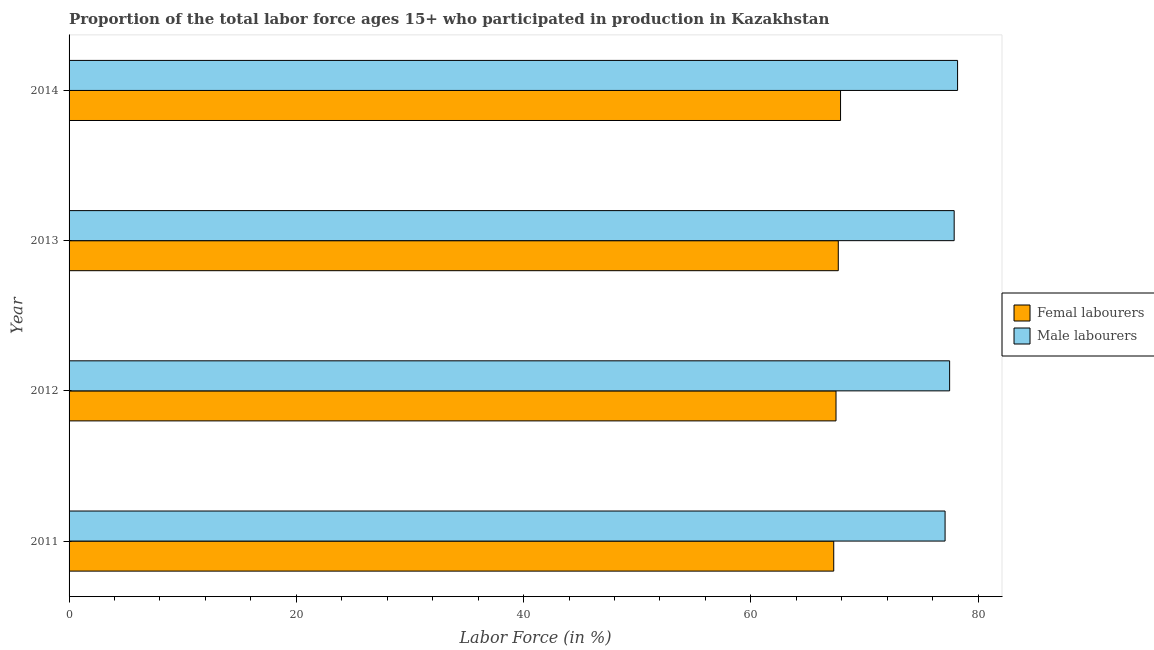How many different coloured bars are there?
Your response must be concise. 2. Are the number of bars per tick equal to the number of legend labels?
Offer a terse response. Yes. Are the number of bars on each tick of the Y-axis equal?
Provide a short and direct response. Yes. How many bars are there on the 1st tick from the bottom?
Your answer should be compact. 2. What is the label of the 1st group of bars from the top?
Give a very brief answer. 2014. What is the percentage of male labour force in 2011?
Provide a short and direct response. 77.1. Across all years, what is the maximum percentage of female labor force?
Provide a succinct answer. 67.9. Across all years, what is the minimum percentage of female labor force?
Ensure brevity in your answer.  67.3. In which year was the percentage of male labour force maximum?
Provide a short and direct response. 2014. What is the total percentage of male labour force in the graph?
Provide a short and direct response. 310.7. What is the difference between the percentage of male labour force in 2011 and the percentage of female labor force in 2012?
Give a very brief answer. 9.6. What is the average percentage of male labour force per year?
Your response must be concise. 77.67. Is the difference between the percentage of female labor force in 2012 and 2014 greater than the difference between the percentage of male labour force in 2012 and 2014?
Your answer should be very brief. Yes. What is the difference between the highest and the second highest percentage of female labor force?
Ensure brevity in your answer.  0.2. What is the difference between the highest and the lowest percentage of male labour force?
Offer a terse response. 1.1. In how many years, is the percentage of male labour force greater than the average percentage of male labour force taken over all years?
Keep it short and to the point. 2. What does the 1st bar from the top in 2012 represents?
Give a very brief answer. Male labourers. What does the 1st bar from the bottom in 2012 represents?
Ensure brevity in your answer.  Femal labourers. How many bars are there?
Offer a terse response. 8. Are all the bars in the graph horizontal?
Provide a succinct answer. Yes. How many years are there in the graph?
Ensure brevity in your answer.  4. What is the difference between two consecutive major ticks on the X-axis?
Provide a short and direct response. 20. Are the values on the major ticks of X-axis written in scientific E-notation?
Your answer should be very brief. No. Does the graph contain grids?
Make the answer very short. No. Where does the legend appear in the graph?
Provide a short and direct response. Center right. How are the legend labels stacked?
Offer a terse response. Vertical. What is the title of the graph?
Your response must be concise. Proportion of the total labor force ages 15+ who participated in production in Kazakhstan. What is the label or title of the Y-axis?
Your answer should be compact. Year. What is the Labor Force (in %) in Femal labourers in 2011?
Provide a short and direct response. 67.3. What is the Labor Force (in %) of Male labourers in 2011?
Your answer should be very brief. 77.1. What is the Labor Force (in %) of Femal labourers in 2012?
Offer a very short reply. 67.5. What is the Labor Force (in %) of Male labourers in 2012?
Provide a succinct answer. 77.5. What is the Labor Force (in %) of Femal labourers in 2013?
Offer a terse response. 67.7. What is the Labor Force (in %) in Male labourers in 2013?
Provide a succinct answer. 77.9. What is the Labor Force (in %) of Femal labourers in 2014?
Keep it short and to the point. 67.9. What is the Labor Force (in %) of Male labourers in 2014?
Keep it short and to the point. 78.2. Across all years, what is the maximum Labor Force (in %) of Femal labourers?
Offer a very short reply. 67.9. Across all years, what is the maximum Labor Force (in %) in Male labourers?
Offer a terse response. 78.2. Across all years, what is the minimum Labor Force (in %) in Femal labourers?
Offer a very short reply. 67.3. Across all years, what is the minimum Labor Force (in %) in Male labourers?
Give a very brief answer. 77.1. What is the total Labor Force (in %) of Femal labourers in the graph?
Ensure brevity in your answer.  270.4. What is the total Labor Force (in %) of Male labourers in the graph?
Offer a very short reply. 310.7. What is the difference between the Labor Force (in %) in Femal labourers in 2011 and that in 2012?
Make the answer very short. -0.2. What is the difference between the Labor Force (in %) in Femal labourers in 2012 and that in 2014?
Your response must be concise. -0.4. What is the difference between the Labor Force (in %) of Femal labourers in 2013 and that in 2014?
Give a very brief answer. -0.2. What is the difference between the Labor Force (in %) in Male labourers in 2013 and that in 2014?
Your response must be concise. -0.3. What is the difference between the Labor Force (in %) in Femal labourers in 2011 and the Labor Force (in %) in Male labourers in 2012?
Offer a very short reply. -10.2. What is the difference between the Labor Force (in %) in Femal labourers in 2011 and the Labor Force (in %) in Male labourers in 2013?
Provide a short and direct response. -10.6. What is the difference between the Labor Force (in %) in Femal labourers in 2012 and the Labor Force (in %) in Male labourers in 2013?
Your answer should be very brief. -10.4. What is the difference between the Labor Force (in %) of Femal labourers in 2012 and the Labor Force (in %) of Male labourers in 2014?
Give a very brief answer. -10.7. What is the average Labor Force (in %) of Femal labourers per year?
Your answer should be compact. 67.6. What is the average Labor Force (in %) in Male labourers per year?
Provide a short and direct response. 77.67. In the year 2011, what is the difference between the Labor Force (in %) in Femal labourers and Labor Force (in %) in Male labourers?
Your answer should be very brief. -9.8. In the year 2012, what is the difference between the Labor Force (in %) in Femal labourers and Labor Force (in %) in Male labourers?
Your answer should be compact. -10. In the year 2013, what is the difference between the Labor Force (in %) in Femal labourers and Labor Force (in %) in Male labourers?
Your response must be concise. -10.2. What is the ratio of the Labor Force (in %) of Femal labourers in 2011 to that in 2012?
Provide a short and direct response. 1. What is the ratio of the Labor Force (in %) of Male labourers in 2011 to that in 2013?
Give a very brief answer. 0.99. What is the ratio of the Labor Force (in %) of Femal labourers in 2011 to that in 2014?
Your answer should be very brief. 0.99. What is the ratio of the Labor Force (in %) of Male labourers in 2011 to that in 2014?
Your answer should be compact. 0.99. What is the ratio of the Labor Force (in %) of Male labourers in 2012 to that in 2013?
Your response must be concise. 0.99. What is the ratio of the Labor Force (in %) of Femal labourers in 2012 to that in 2014?
Provide a succinct answer. 0.99. What is the ratio of the Labor Force (in %) of Femal labourers in 2013 to that in 2014?
Provide a short and direct response. 1. What is the difference between the highest and the second highest Labor Force (in %) of Femal labourers?
Your answer should be compact. 0.2. 